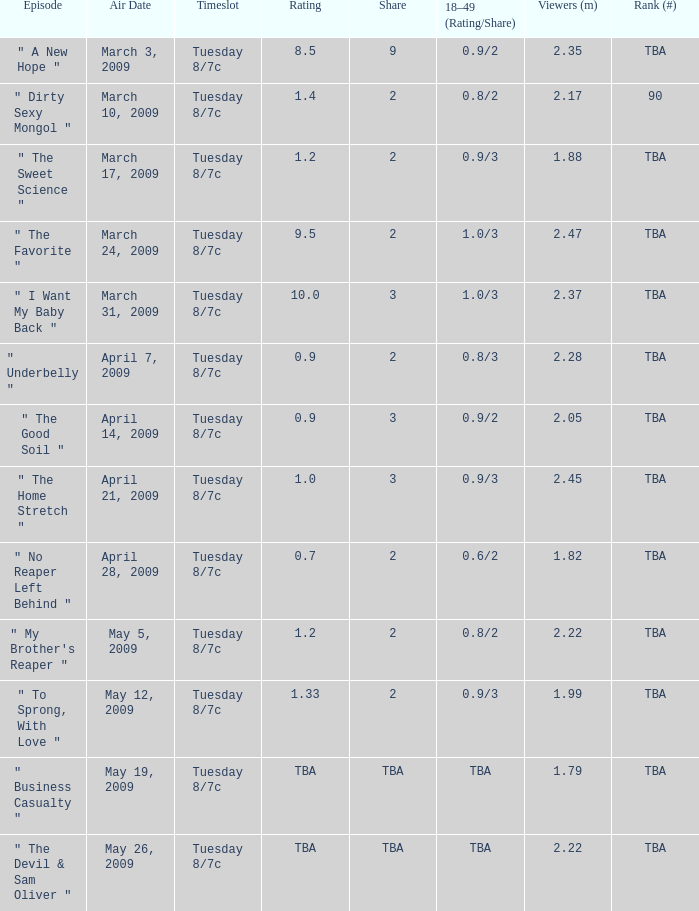In terms of 18-49 (rating/share), what does the proportion 0.8/3 signify? 2.0. 